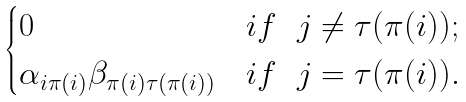Convert formula to latex. <formula><loc_0><loc_0><loc_500><loc_500>\begin{cases} 0 & i f \ \ j \ne \tau ( \pi ( i ) ) ; \\ \alpha _ { i \pi ( i ) } \beta _ { \pi ( i ) \tau ( \pi ( i ) ) } & i f \ \ j = \tau ( \pi ( i ) ) . \\ \end{cases}</formula> 